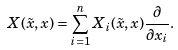<formula> <loc_0><loc_0><loc_500><loc_500>X ( \tilde { x } , x ) = \sum _ { i = 1 } ^ { n } X _ { i } ( \tilde { x } , x ) \frac { \partial } { \partial x _ { i } } .</formula> 